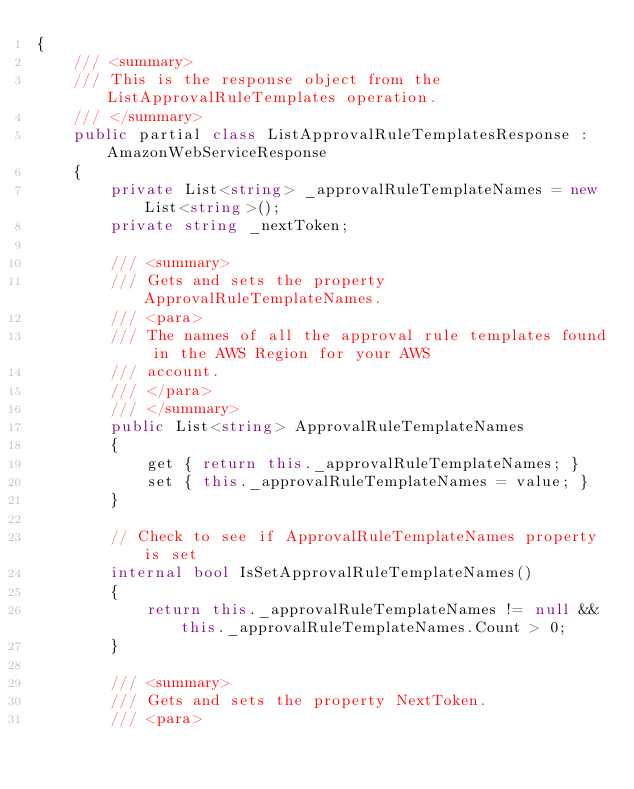<code> <loc_0><loc_0><loc_500><loc_500><_C#_>{
    /// <summary>
    /// This is the response object from the ListApprovalRuleTemplates operation.
    /// </summary>
    public partial class ListApprovalRuleTemplatesResponse : AmazonWebServiceResponse
    {
        private List<string> _approvalRuleTemplateNames = new List<string>();
        private string _nextToken;

        /// <summary>
        /// Gets and sets the property ApprovalRuleTemplateNames. 
        /// <para>
        /// The names of all the approval rule templates found in the AWS Region for your AWS
        /// account.
        /// </para>
        /// </summary>
        public List<string> ApprovalRuleTemplateNames
        {
            get { return this._approvalRuleTemplateNames; }
            set { this._approvalRuleTemplateNames = value; }
        }

        // Check to see if ApprovalRuleTemplateNames property is set
        internal bool IsSetApprovalRuleTemplateNames()
        {
            return this._approvalRuleTemplateNames != null && this._approvalRuleTemplateNames.Count > 0; 
        }

        /// <summary>
        /// Gets and sets the property NextToken. 
        /// <para></code> 